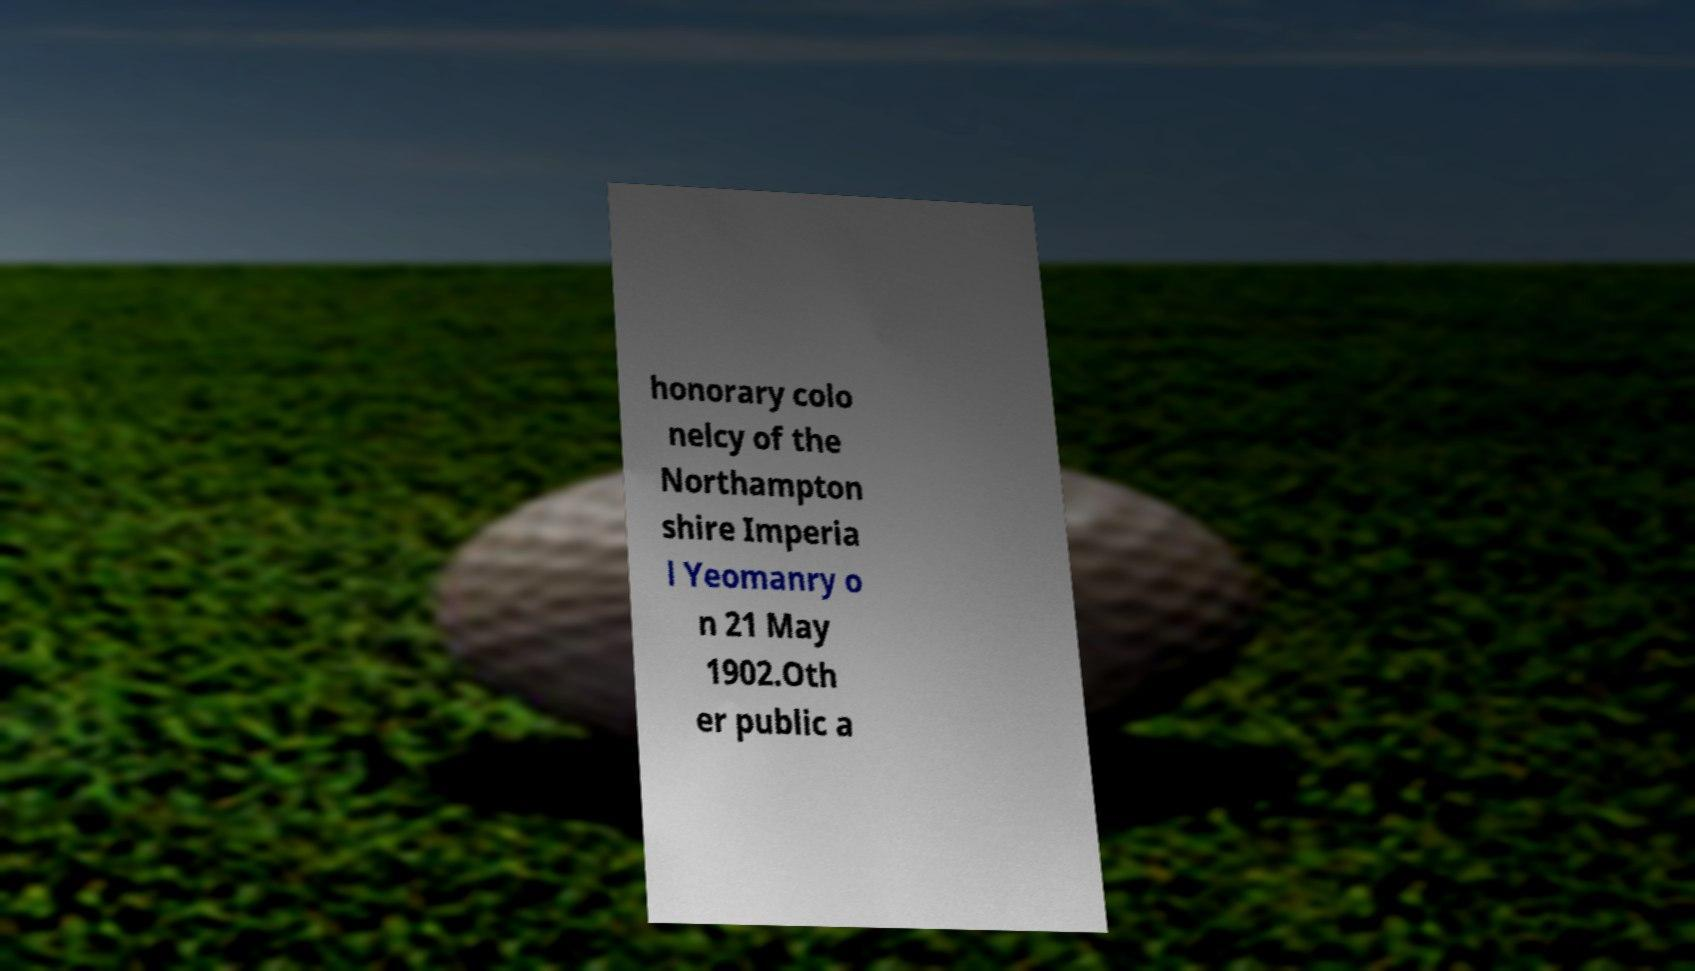Please read and relay the text visible in this image. What does it say? honorary colo nelcy of the Northampton shire Imperia l Yeomanry o n 21 May 1902.Oth er public a 